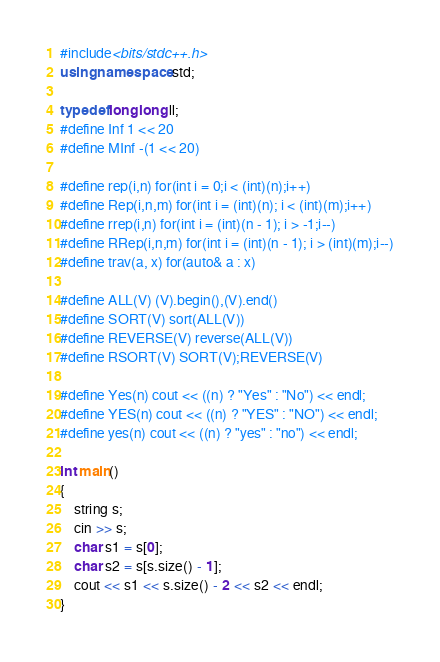<code> <loc_0><loc_0><loc_500><loc_500><_C++_>#include<bits/stdc++.h>
using namespace std;

typedef long long ll;
#define Inf 1 << 20
#define MInf -(1 << 20)
 
#define rep(i,n) for(int i = 0;i < (int)(n);i++)
#define Rep(i,n,m) for(int i = (int)(n); i < (int)(m);i++)
#define rrep(i,n) for(int i = (int)(n - 1); i > -1;i--)
#define RRep(i,n,m) for(int i = (int)(n - 1); i > (int)(m);i--)
#define trav(a, x) for(auto& a : x)
 
#define ALL(V) (V).begin(),(V).end()
#define SORT(V) sort(ALL(V))
#define REVERSE(V) reverse(ALL(V))
#define RSORT(V) SORT(V);REVERSE(V)
 
#define Yes(n) cout << ((n) ? "Yes" : "No") << endl;
#define YES(n) cout << ((n) ? "YES" : "NO") << endl;
#define yes(n) cout << ((n) ? "yes" : "no") << endl;

int main()
{
    string s;
    cin >> s;
    char s1 = s[0];
    char s2 = s[s.size() - 1];
    cout << s1 << s.size() - 2 << s2 << endl;
}
</code> 